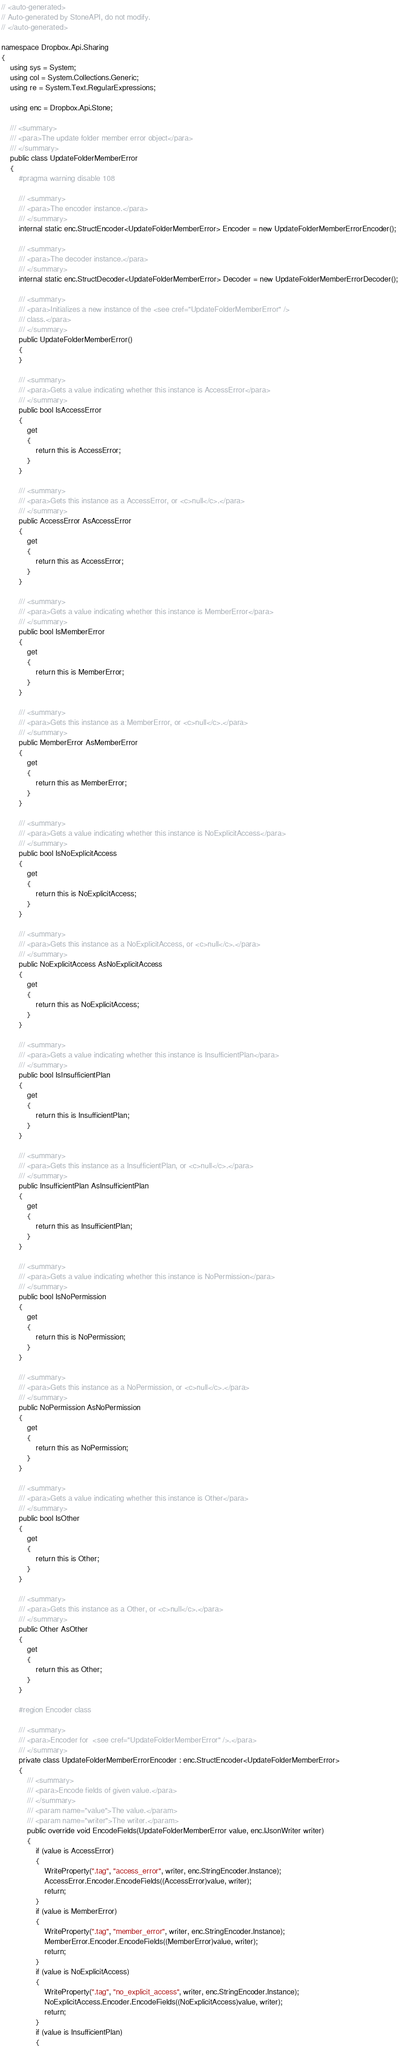Convert code to text. <code><loc_0><loc_0><loc_500><loc_500><_C#_>// <auto-generated>
// Auto-generated by StoneAPI, do not modify.
// </auto-generated>

namespace Dropbox.Api.Sharing
{
    using sys = System;
    using col = System.Collections.Generic;
    using re = System.Text.RegularExpressions;

    using enc = Dropbox.Api.Stone;

    /// <summary>
    /// <para>The update folder member error object</para>
    /// </summary>
    public class UpdateFolderMemberError
    {
        #pragma warning disable 108

        /// <summary>
        /// <para>The encoder instance.</para>
        /// </summary>
        internal static enc.StructEncoder<UpdateFolderMemberError> Encoder = new UpdateFolderMemberErrorEncoder();

        /// <summary>
        /// <para>The decoder instance.</para>
        /// </summary>
        internal static enc.StructDecoder<UpdateFolderMemberError> Decoder = new UpdateFolderMemberErrorDecoder();

        /// <summary>
        /// <para>Initializes a new instance of the <see cref="UpdateFolderMemberError" />
        /// class.</para>
        /// </summary>
        public UpdateFolderMemberError()
        {
        }

        /// <summary>
        /// <para>Gets a value indicating whether this instance is AccessError</para>
        /// </summary>
        public bool IsAccessError
        {
            get
            {
                return this is AccessError;
            }
        }

        /// <summary>
        /// <para>Gets this instance as a AccessError, or <c>null</c>.</para>
        /// </summary>
        public AccessError AsAccessError
        {
            get
            {
                return this as AccessError;
            }
        }

        /// <summary>
        /// <para>Gets a value indicating whether this instance is MemberError</para>
        /// </summary>
        public bool IsMemberError
        {
            get
            {
                return this is MemberError;
            }
        }

        /// <summary>
        /// <para>Gets this instance as a MemberError, or <c>null</c>.</para>
        /// </summary>
        public MemberError AsMemberError
        {
            get
            {
                return this as MemberError;
            }
        }

        /// <summary>
        /// <para>Gets a value indicating whether this instance is NoExplicitAccess</para>
        /// </summary>
        public bool IsNoExplicitAccess
        {
            get
            {
                return this is NoExplicitAccess;
            }
        }

        /// <summary>
        /// <para>Gets this instance as a NoExplicitAccess, or <c>null</c>.</para>
        /// </summary>
        public NoExplicitAccess AsNoExplicitAccess
        {
            get
            {
                return this as NoExplicitAccess;
            }
        }

        /// <summary>
        /// <para>Gets a value indicating whether this instance is InsufficientPlan</para>
        /// </summary>
        public bool IsInsufficientPlan
        {
            get
            {
                return this is InsufficientPlan;
            }
        }

        /// <summary>
        /// <para>Gets this instance as a InsufficientPlan, or <c>null</c>.</para>
        /// </summary>
        public InsufficientPlan AsInsufficientPlan
        {
            get
            {
                return this as InsufficientPlan;
            }
        }

        /// <summary>
        /// <para>Gets a value indicating whether this instance is NoPermission</para>
        /// </summary>
        public bool IsNoPermission
        {
            get
            {
                return this is NoPermission;
            }
        }

        /// <summary>
        /// <para>Gets this instance as a NoPermission, or <c>null</c>.</para>
        /// </summary>
        public NoPermission AsNoPermission
        {
            get
            {
                return this as NoPermission;
            }
        }

        /// <summary>
        /// <para>Gets a value indicating whether this instance is Other</para>
        /// </summary>
        public bool IsOther
        {
            get
            {
                return this is Other;
            }
        }

        /// <summary>
        /// <para>Gets this instance as a Other, or <c>null</c>.</para>
        /// </summary>
        public Other AsOther
        {
            get
            {
                return this as Other;
            }
        }

        #region Encoder class

        /// <summary>
        /// <para>Encoder for  <see cref="UpdateFolderMemberError" />.</para>
        /// </summary>
        private class UpdateFolderMemberErrorEncoder : enc.StructEncoder<UpdateFolderMemberError>
        {
            /// <summary>
            /// <para>Encode fields of given value.</para>
            /// </summary>
            /// <param name="value">The value.</param>
            /// <param name="writer">The writer.</param>
            public override void EncodeFields(UpdateFolderMemberError value, enc.IJsonWriter writer)
            {
                if (value is AccessError)
                {
                    WriteProperty(".tag", "access_error", writer, enc.StringEncoder.Instance);
                    AccessError.Encoder.EncodeFields((AccessError)value, writer);
                    return;
                }
                if (value is MemberError)
                {
                    WriteProperty(".tag", "member_error", writer, enc.StringEncoder.Instance);
                    MemberError.Encoder.EncodeFields((MemberError)value, writer);
                    return;
                }
                if (value is NoExplicitAccess)
                {
                    WriteProperty(".tag", "no_explicit_access", writer, enc.StringEncoder.Instance);
                    NoExplicitAccess.Encoder.EncodeFields((NoExplicitAccess)value, writer);
                    return;
                }
                if (value is InsufficientPlan)
                {</code> 